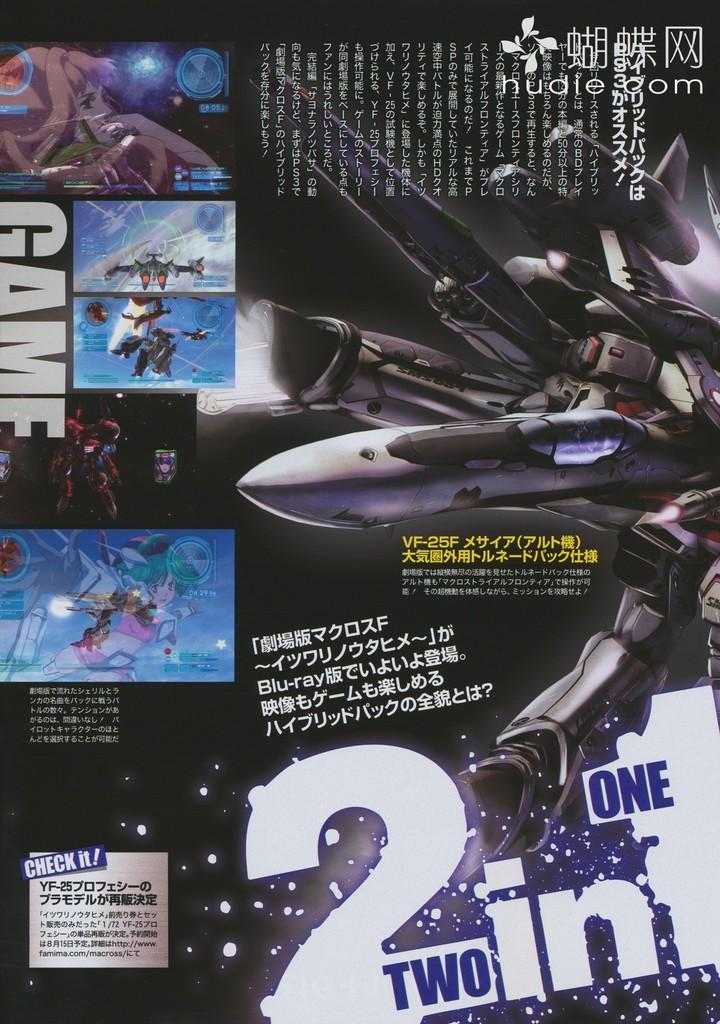<image>
Create a compact narrative representing the image presented. A poster with a fighter jet on it that says Two in One. 